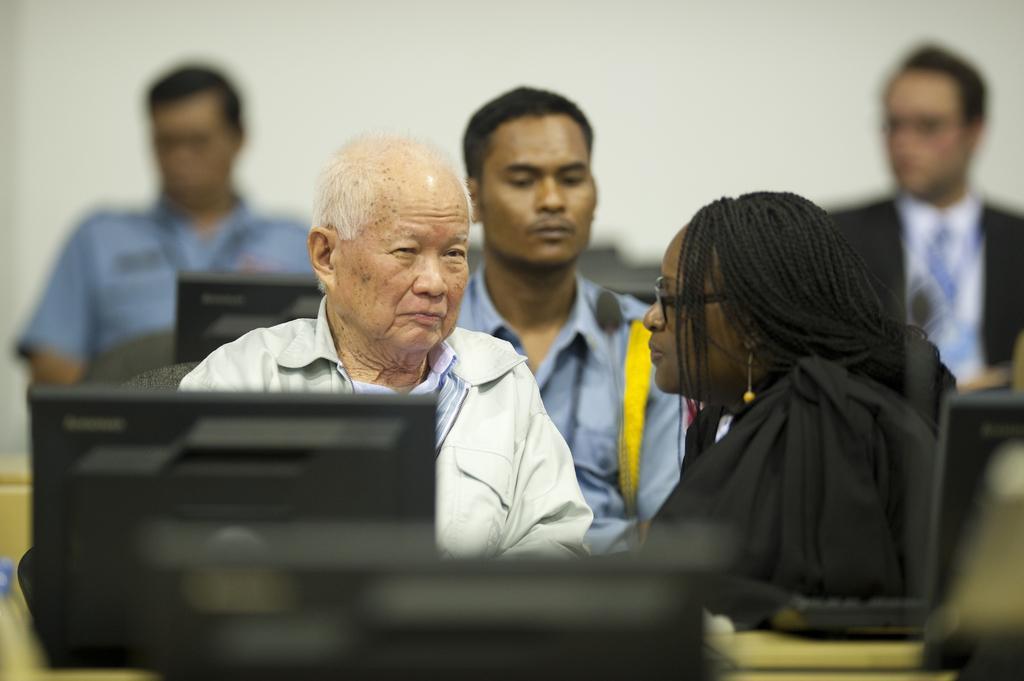Can you describe this image briefly? On the right side of the image there is a lady with spectacles is sitting. In front of her there is an old man. At the bottom of the image there are monitors. In the background there are three men and also there are monitors. 